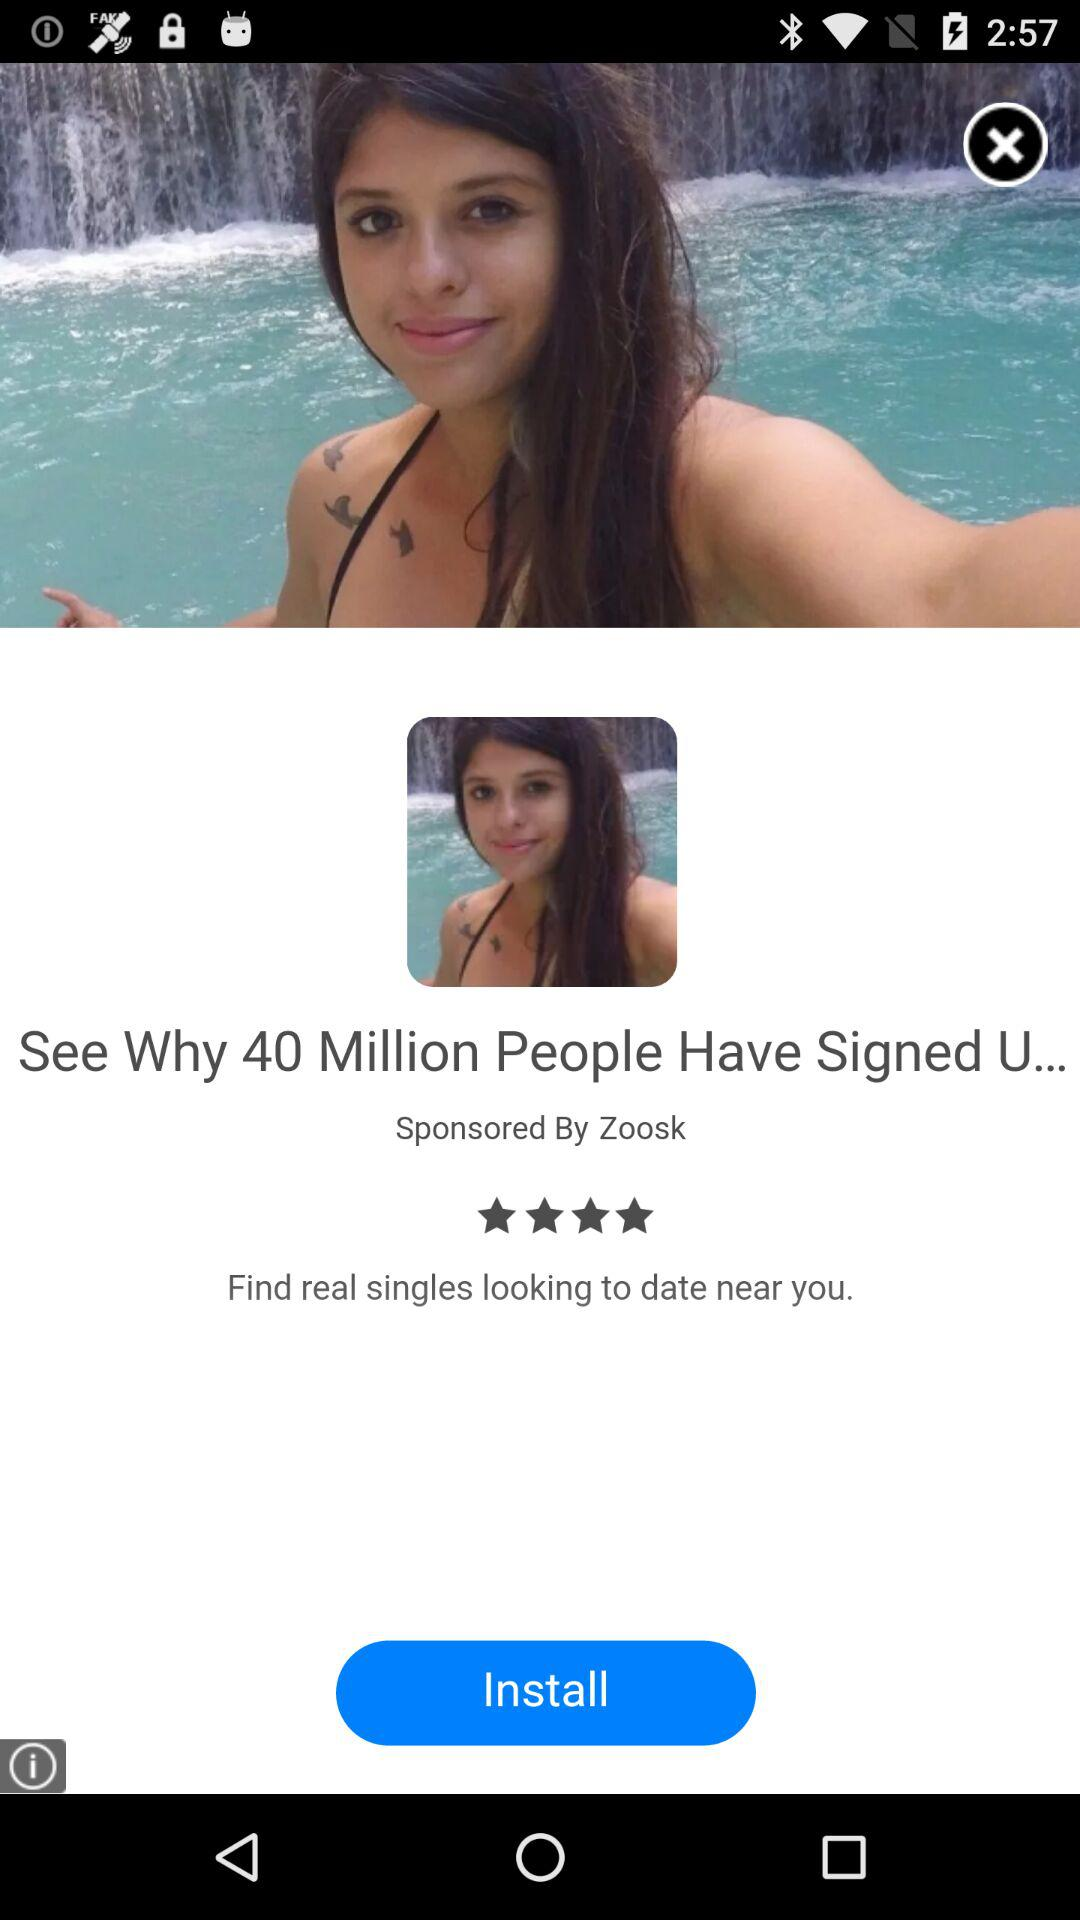What are the ratings? The rating is 4 stars. 